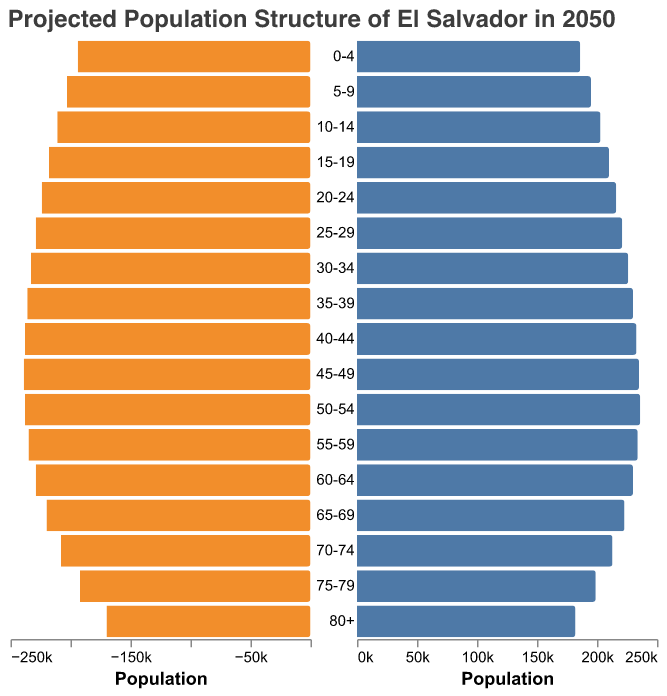What is the total male population in the age group 0-4? To find the total male population in the age group 0-4, refer to the bar chart. The value is given as 194,000.
Answer: 194,000 What is the difference in population between males and females aged 80+? To find the difference, locate the populations for males and females in the age group 80+. Males have 170,000, and females have 182,000. Subtract 170,000 from 182,000 to get the difference.
Answer: 12,000 In which age group is the population of males the highest? To find the age group with the highest male population, compare the heights of the bars representing males across all age groups. The tallest bar for males is in the age group 45-49, which has a population of 239,000.
Answer: 45-49 Comparing the age groups 30-34 and 75-79, which gender and age group has the larger population? Examine the bars for both males and females in the age groups 30-34 and 75-79. Males aged 30-34 have a population of 233,000, and males aged 75-79 have 192,000. Females aged 30-34 have 226,000, and females aged 75-79 have 199,000. The largest population is for males aged 30-34.
Answer: Males aged 30-34 What’s the average population of females in the age groups from 60-64 to 70-74? To find the average, add the population of females in the age groups 60-64, 65-69, and 70-74. The populations are 230,000, 223,000, and 213,000 respectively. The total is 666,000. Divide by 3.
Answer: 222,000 How does the population of females aged 50-54 compare to that of males aged 55-59? Look at the populations: females aged 50-54 have 236,000, and males aged 55-59 have 235,000. The populations are nearly equal, with females having a slightly higher population by 1,000.
Answer: Females aged 50-54 are slightly higher by 1,000 What proportion of the total population for ages 0-4 is male? Calculate the total population for ages 0-4 by adding male and female populations (194,000 + 186,000 = 380,000). To find the proportion of males, divide the male population by the total (194,000 / 380,000). Convert to a percentage by multiplying by 100.
Answer: 51.05% Across all age groups, are there any where the female population exceeds the male population? Compare the heights of bars for males and females in each age group. In the age group 80+, females (182,000) exceed males (170,000).
Answer: Yes, in the age group 80+ 